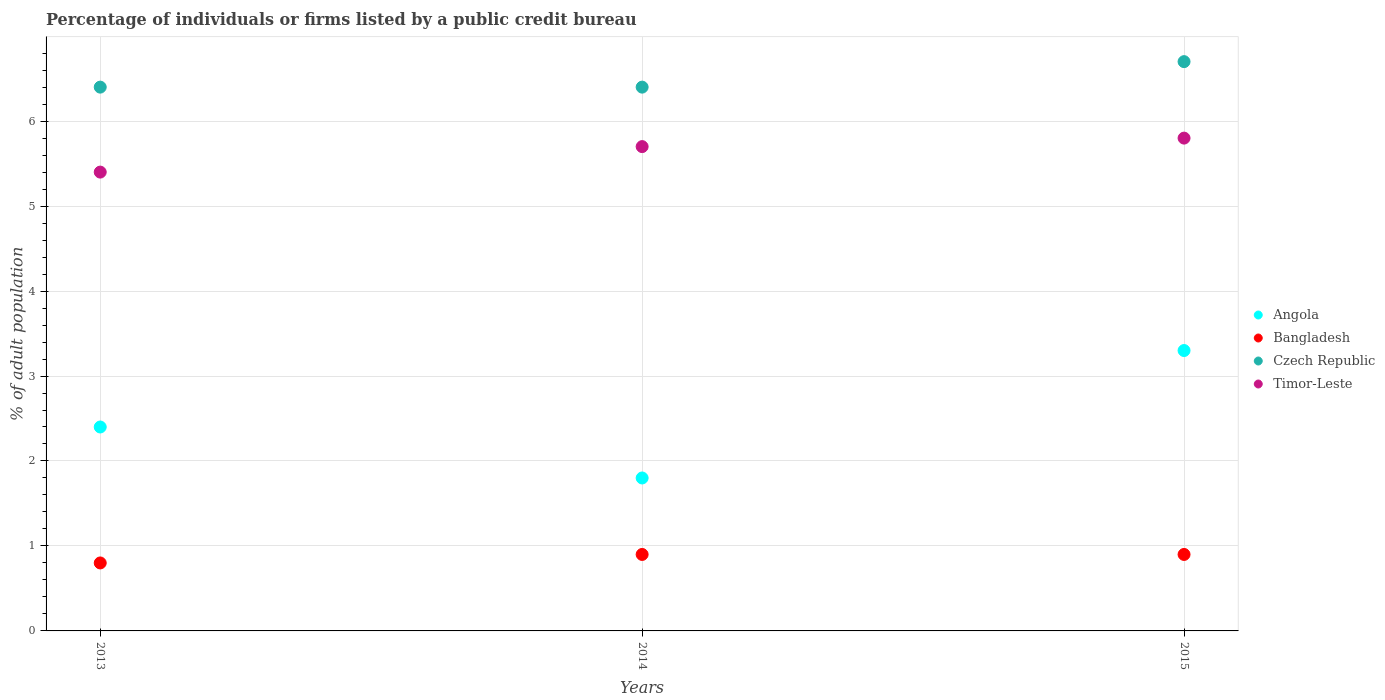How many different coloured dotlines are there?
Your response must be concise. 4. Is the number of dotlines equal to the number of legend labels?
Ensure brevity in your answer.  Yes. Across all years, what is the minimum percentage of population listed by a public credit bureau in Bangladesh?
Offer a very short reply. 0.8. In which year was the percentage of population listed by a public credit bureau in Bangladesh maximum?
Your answer should be compact. 2014. What is the total percentage of population listed by a public credit bureau in Czech Republic in the graph?
Ensure brevity in your answer.  19.5. What is the difference between the percentage of population listed by a public credit bureau in Timor-Leste in 2014 and that in 2015?
Make the answer very short. -0.1. What is the difference between the percentage of population listed by a public credit bureau in Timor-Leste in 2015 and the percentage of population listed by a public credit bureau in Bangladesh in 2013?
Your response must be concise. 5. What is the average percentage of population listed by a public credit bureau in Timor-Leste per year?
Provide a succinct answer. 5.63. In the year 2013, what is the difference between the percentage of population listed by a public credit bureau in Angola and percentage of population listed by a public credit bureau in Bangladesh?
Provide a succinct answer. 1.6. What is the ratio of the percentage of population listed by a public credit bureau in Czech Republic in 2014 to that in 2015?
Ensure brevity in your answer.  0.96. Is the percentage of population listed by a public credit bureau in Czech Republic in 2014 less than that in 2015?
Your answer should be compact. Yes. What is the difference between the highest and the second highest percentage of population listed by a public credit bureau in Czech Republic?
Your response must be concise. 0.3. What is the difference between the highest and the lowest percentage of population listed by a public credit bureau in Angola?
Offer a very short reply. 1.5. How many dotlines are there?
Offer a very short reply. 4. How many years are there in the graph?
Make the answer very short. 3. Does the graph contain any zero values?
Offer a terse response. No. How are the legend labels stacked?
Your answer should be very brief. Vertical. What is the title of the graph?
Provide a succinct answer. Percentage of individuals or firms listed by a public credit bureau. What is the label or title of the X-axis?
Ensure brevity in your answer.  Years. What is the label or title of the Y-axis?
Your answer should be very brief. % of adult population. What is the % of adult population of Angola in 2013?
Ensure brevity in your answer.  2.4. What is the % of adult population in Timor-Leste in 2015?
Offer a terse response. 5.8. Across all years, what is the maximum % of adult population in Bangladesh?
Provide a succinct answer. 0.9. Across all years, what is the minimum % of adult population of Angola?
Provide a succinct answer. 1.8. Across all years, what is the minimum % of adult population of Czech Republic?
Ensure brevity in your answer.  6.4. Across all years, what is the minimum % of adult population in Timor-Leste?
Make the answer very short. 5.4. What is the total % of adult population in Angola in the graph?
Keep it short and to the point. 7.5. What is the total % of adult population of Bangladesh in the graph?
Offer a terse response. 2.6. What is the total % of adult population in Czech Republic in the graph?
Make the answer very short. 19.5. What is the difference between the % of adult population of Angola in 2013 and that in 2014?
Your answer should be compact. 0.6. What is the difference between the % of adult population in Bangladesh in 2013 and that in 2014?
Your answer should be compact. -0.1. What is the difference between the % of adult population in Czech Republic in 2013 and that in 2014?
Your response must be concise. 0. What is the difference between the % of adult population of Timor-Leste in 2013 and that in 2014?
Keep it short and to the point. -0.3. What is the difference between the % of adult population of Angola in 2013 and that in 2015?
Keep it short and to the point. -0.9. What is the difference between the % of adult population of Czech Republic in 2013 and that in 2015?
Offer a very short reply. -0.3. What is the difference between the % of adult population of Timor-Leste in 2013 and that in 2015?
Provide a short and direct response. -0.4. What is the difference between the % of adult population in Angola in 2014 and that in 2015?
Offer a very short reply. -1.5. What is the difference between the % of adult population in Bangladesh in 2014 and that in 2015?
Provide a short and direct response. 0. What is the difference between the % of adult population of Czech Republic in 2014 and that in 2015?
Your answer should be compact. -0.3. What is the difference between the % of adult population of Timor-Leste in 2014 and that in 2015?
Make the answer very short. -0.1. What is the difference between the % of adult population in Angola in 2013 and the % of adult population in Timor-Leste in 2014?
Your response must be concise. -3.3. What is the difference between the % of adult population in Bangladesh in 2013 and the % of adult population in Timor-Leste in 2014?
Offer a terse response. -4.9. What is the difference between the % of adult population of Angola in 2013 and the % of adult population of Bangladesh in 2015?
Your response must be concise. 1.5. What is the difference between the % of adult population of Angola in 2013 and the % of adult population of Czech Republic in 2015?
Give a very brief answer. -4.3. What is the difference between the % of adult population of Angola in 2013 and the % of adult population of Timor-Leste in 2015?
Your answer should be compact. -3.4. What is the difference between the % of adult population of Czech Republic in 2013 and the % of adult population of Timor-Leste in 2015?
Your response must be concise. 0.6. What is the difference between the % of adult population of Angola in 2014 and the % of adult population of Czech Republic in 2015?
Your answer should be very brief. -4.9. What is the difference between the % of adult population of Bangladesh in 2014 and the % of adult population of Czech Republic in 2015?
Make the answer very short. -5.8. What is the difference between the % of adult population in Bangladesh in 2014 and the % of adult population in Timor-Leste in 2015?
Your answer should be very brief. -4.9. What is the average % of adult population of Bangladesh per year?
Provide a succinct answer. 0.87. What is the average % of adult population of Timor-Leste per year?
Offer a very short reply. 5.63. In the year 2013, what is the difference between the % of adult population in Angola and % of adult population in Czech Republic?
Your response must be concise. -4. In the year 2013, what is the difference between the % of adult population in Bangladesh and % of adult population in Czech Republic?
Provide a short and direct response. -5.6. In the year 2013, what is the difference between the % of adult population of Bangladesh and % of adult population of Timor-Leste?
Make the answer very short. -4.6. In the year 2014, what is the difference between the % of adult population in Bangladesh and % of adult population in Timor-Leste?
Your response must be concise. -4.8. In the year 2014, what is the difference between the % of adult population in Czech Republic and % of adult population in Timor-Leste?
Provide a succinct answer. 0.7. In the year 2015, what is the difference between the % of adult population of Bangladesh and % of adult population of Timor-Leste?
Provide a short and direct response. -4.9. In the year 2015, what is the difference between the % of adult population of Czech Republic and % of adult population of Timor-Leste?
Your answer should be compact. 0.9. What is the ratio of the % of adult population in Czech Republic in 2013 to that in 2014?
Offer a very short reply. 1. What is the ratio of the % of adult population of Timor-Leste in 2013 to that in 2014?
Keep it short and to the point. 0.95. What is the ratio of the % of adult population of Angola in 2013 to that in 2015?
Ensure brevity in your answer.  0.73. What is the ratio of the % of adult population in Bangladesh in 2013 to that in 2015?
Your response must be concise. 0.89. What is the ratio of the % of adult population in Czech Republic in 2013 to that in 2015?
Provide a short and direct response. 0.96. What is the ratio of the % of adult population of Angola in 2014 to that in 2015?
Your answer should be very brief. 0.55. What is the ratio of the % of adult population of Czech Republic in 2014 to that in 2015?
Offer a terse response. 0.96. What is the ratio of the % of adult population in Timor-Leste in 2014 to that in 2015?
Your response must be concise. 0.98. What is the difference between the highest and the second highest % of adult population in Angola?
Ensure brevity in your answer.  0.9. What is the difference between the highest and the second highest % of adult population of Bangladesh?
Keep it short and to the point. 0. What is the difference between the highest and the second highest % of adult population of Timor-Leste?
Your answer should be compact. 0.1. What is the difference between the highest and the lowest % of adult population in Angola?
Ensure brevity in your answer.  1.5. What is the difference between the highest and the lowest % of adult population in Czech Republic?
Make the answer very short. 0.3. What is the difference between the highest and the lowest % of adult population in Timor-Leste?
Your answer should be very brief. 0.4. 